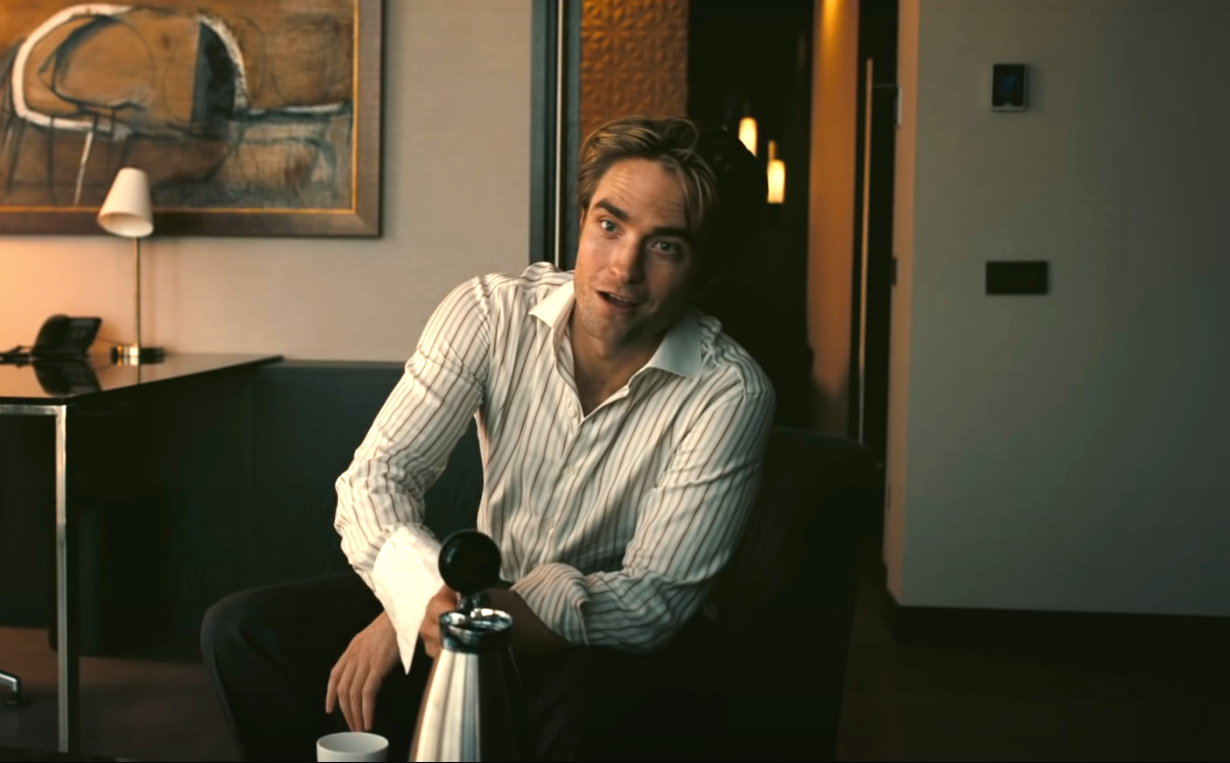How does the choice of furniture and decoration affect the overall impression of the scene? The choice of furniture and decoration greatly enhances the overall impression of sophistication and tranquility in the scene. The black leather couch adds a touch of modern elegance, while the painting and lamp in the background contribute to a cultured and artistic atmosphere. The muted colors and soft lighting create a calm and inviting space, making the room feel both refined and comfortable. This careful selection of decor elements suggests that the man values both style and comfort, which complements his relaxed and content demeanor. 